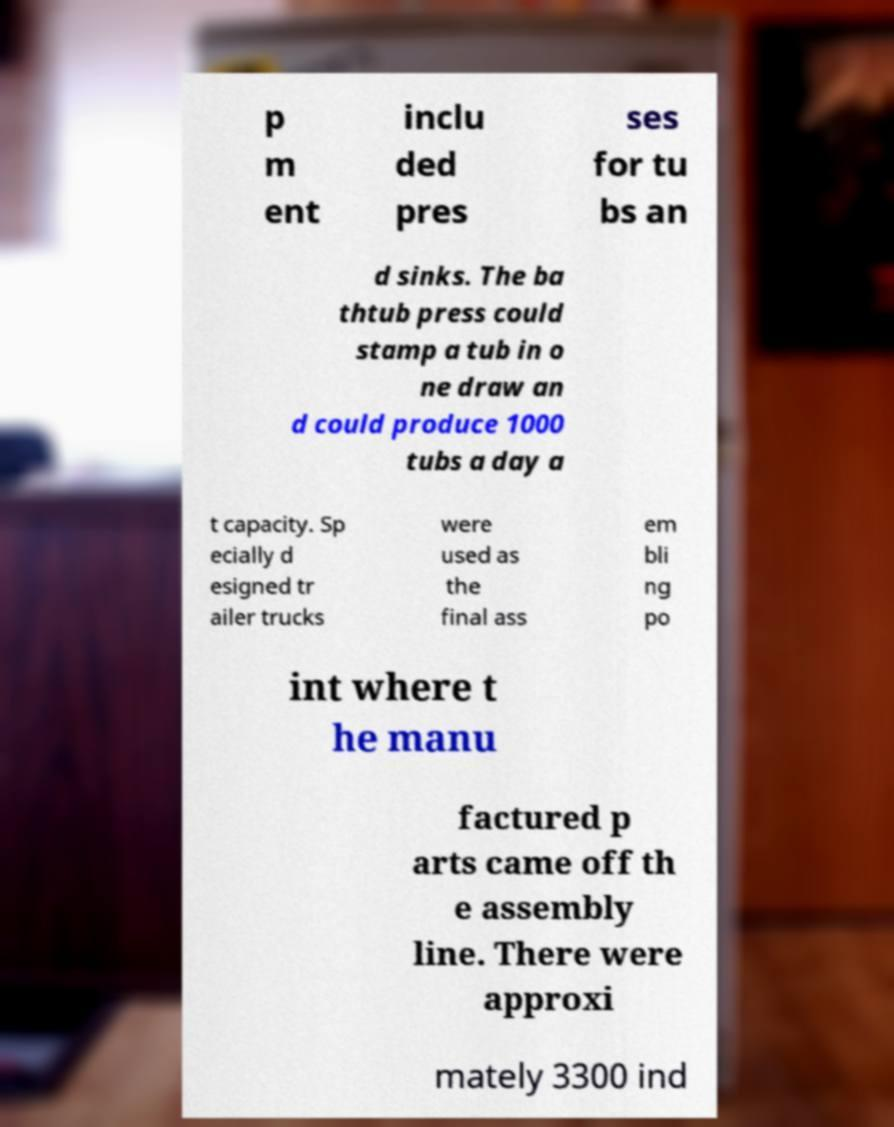Please read and relay the text visible in this image. What does it say? p m ent inclu ded pres ses for tu bs an d sinks. The ba thtub press could stamp a tub in o ne draw an d could produce 1000 tubs a day a t capacity. Sp ecially d esigned tr ailer trucks were used as the final ass em bli ng po int where t he manu factured p arts came off th e assembly line. There were approxi mately 3300 ind 